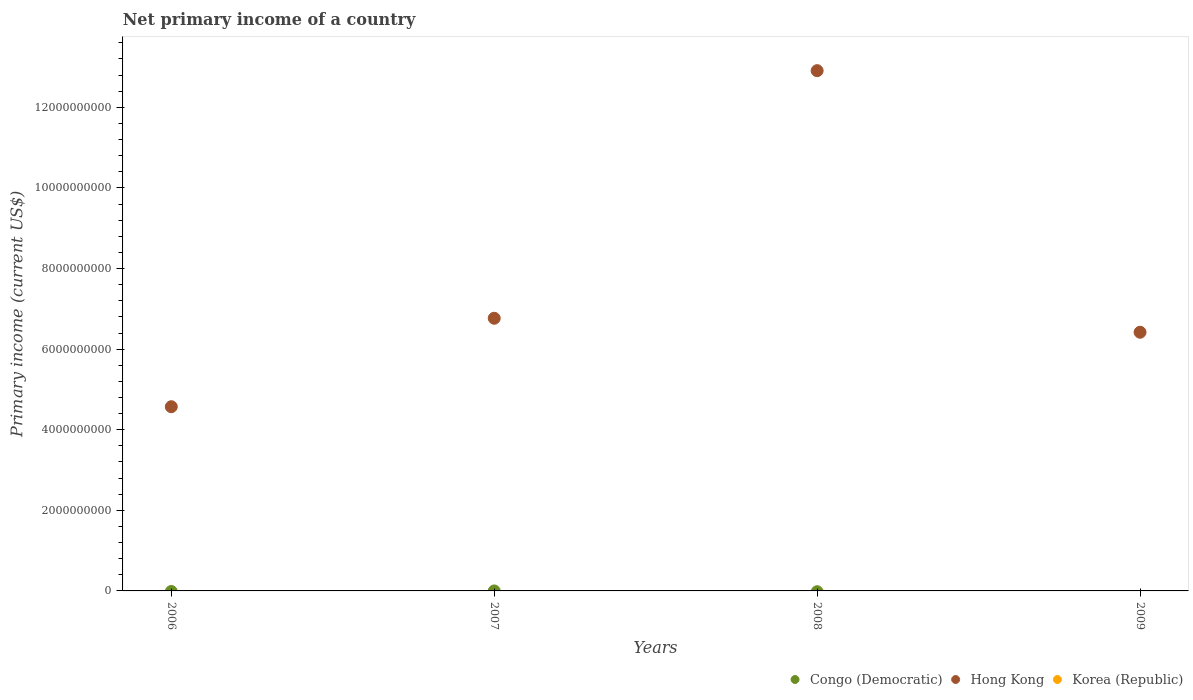How many different coloured dotlines are there?
Provide a succinct answer. 1. Across all years, what is the maximum primary income in Hong Kong?
Make the answer very short. 1.29e+1. Across all years, what is the minimum primary income in Congo (Democratic)?
Ensure brevity in your answer.  0. What is the total primary income in Congo (Democratic) in the graph?
Keep it short and to the point. 0. What is the difference between the primary income in Hong Kong in 2008 and that in 2009?
Ensure brevity in your answer.  6.49e+09. What is the difference between the primary income in Congo (Democratic) in 2008 and the primary income in Korea (Republic) in 2009?
Keep it short and to the point. 0. What is the average primary income in Congo (Democratic) per year?
Your response must be concise. 0. What is the ratio of the primary income in Hong Kong in 2008 to that in 2009?
Your answer should be compact. 2.01. What is the difference between the highest and the second highest primary income in Hong Kong?
Provide a short and direct response. 6.14e+09. What is the difference between the highest and the lowest primary income in Hong Kong?
Keep it short and to the point. 8.34e+09. In how many years, is the primary income in Hong Kong greater than the average primary income in Hong Kong taken over all years?
Make the answer very short. 1. Is the sum of the primary income in Hong Kong in 2006 and 2007 greater than the maximum primary income in Congo (Democratic) across all years?
Ensure brevity in your answer.  Yes. Is it the case that in every year, the sum of the primary income in Hong Kong and primary income in Korea (Republic)  is greater than the primary income in Congo (Democratic)?
Offer a terse response. Yes. How many dotlines are there?
Offer a terse response. 1. How many years are there in the graph?
Your response must be concise. 4. What is the difference between two consecutive major ticks on the Y-axis?
Your answer should be very brief. 2.00e+09. Does the graph contain any zero values?
Ensure brevity in your answer.  Yes. Does the graph contain grids?
Your answer should be very brief. No. What is the title of the graph?
Offer a very short reply. Net primary income of a country. What is the label or title of the Y-axis?
Offer a very short reply. Primary income (current US$). What is the Primary income (current US$) in Congo (Democratic) in 2006?
Your response must be concise. 0. What is the Primary income (current US$) in Hong Kong in 2006?
Give a very brief answer. 4.57e+09. What is the Primary income (current US$) in Hong Kong in 2007?
Make the answer very short. 6.77e+09. What is the Primary income (current US$) in Congo (Democratic) in 2008?
Your answer should be very brief. 0. What is the Primary income (current US$) in Hong Kong in 2008?
Offer a very short reply. 1.29e+1. What is the Primary income (current US$) of Korea (Republic) in 2008?
Your answer should be compact. 0. What is the Primary income (current US$) in Congo (Democratic) in 2009?
Your answer should be very brief. 0. What is the Primary income (current US$) in Hong Kong in 2009?
Provide a succinct answer. 6.42e+09. Across all years, what is the maximum Primary income (current US$) of Hong Kong?
Your answer should be very brief. 1.29e+1. Across all years, what is the minimum Primary income (current US$) of Hong Kong?
Ensure brevity in your answer.  4.57e+09. What is the total Primary income (current US$) of Congo (Democratic) in the graph?
Your answer should be compact. 0. What is the total Primary income (current US$) of Hong Kong in the graph?
Your answer should be compact. 3.07e+1. What is the difference between the Primary income (current US$) in Hong Kong in 2006 and that in 2007?
Offer a very short reply. -2.20e+09. What is the difference between the Primary income (current US$) in Hong Kong in 2006 and that in 2008?
Offer a terse response. -8.34e+09. What is the difference between the Primary income (current US$) of Hong Kong in 2006 and that in 2009?
Ensure brevity in your answer.  -1.85e+09. What is the difference between the Primary income (current US$) of Hong Kong in 2007 and that in 2008?
Ensure brevity in your answer.  -6.14e+09. What is the difference between the Primary income (current US$) of Hong Kong in 2007 and that in 2009?
Keep it short and to the point. 3.47e+08. What is the difference between the Primary income (current US$) in Hong Kong in 2008 and that in 2009?
Your answer should be very brief. 6.49e+09. What is the average Primary income (current US$) of Hong Kong per year?
Your answer should be compact. 7.67e+09. What is the ratio of the Primary income (current US$) of Hong Kong in 2006 to that in 2007?
Your answer should be compact. 0.68. What is the ratio of the Primary income (current US$) in Hong Kong in 2006 to that in 2008?
Provide a short and direct response. 0.35. What is the ratio of the Primary income (current US$) of Hong Kong in 2006 to that in 2009?
Offer a very short reply. 0.71. What is the ratio of the Primary income (current US$) of Hong Kong in 2007 to that in 2008?
Ensure brevity in your answer.  0.52. What is the ratio of the Primary income (current US$) in Hong Kong in 2007 to that in 2009?
Provide a succinct answer. 1.05. What is the ratio of the Primary income (current US$) of Hong Kong in 2008 to that in 2009?
Ensure brevity in your answer.  2.01. What is the difference between the highest and the second highest Primary income (current US$) in Hong Kong?
Your response must be concise. 6.14e+09. What is the difference between the highest and the lowest Primary income (current US$) in Hong Kong?
Make the answer very short. 8.34e+09. 